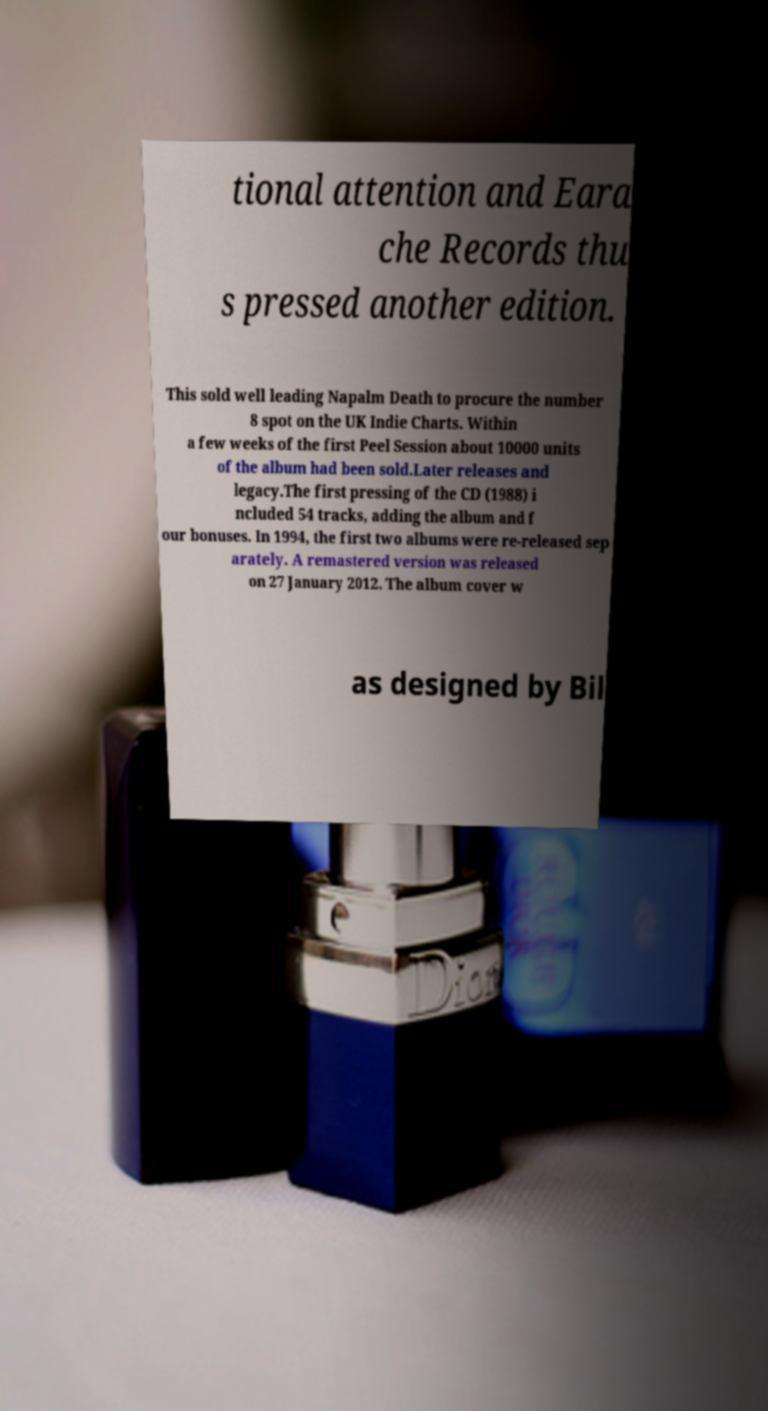Please identify and transcribe the text found in this image. tional attention and Eara che Records thu s pressed another edition. This sold well leading Napalm Death to procure the number 8 spot on the UK Indie Charts. Within a few weeks of the first Peel Session about 10000 units of the album had been sold.Later releases and legacy.The first pressing of the CD (1988) i ncluded 54 tracks, adding the album and f our bonuses. In 1994, the first two albums were re-released sep arately. A remastered version was released on 27 January 2012. The album cover w as designed by Bil 